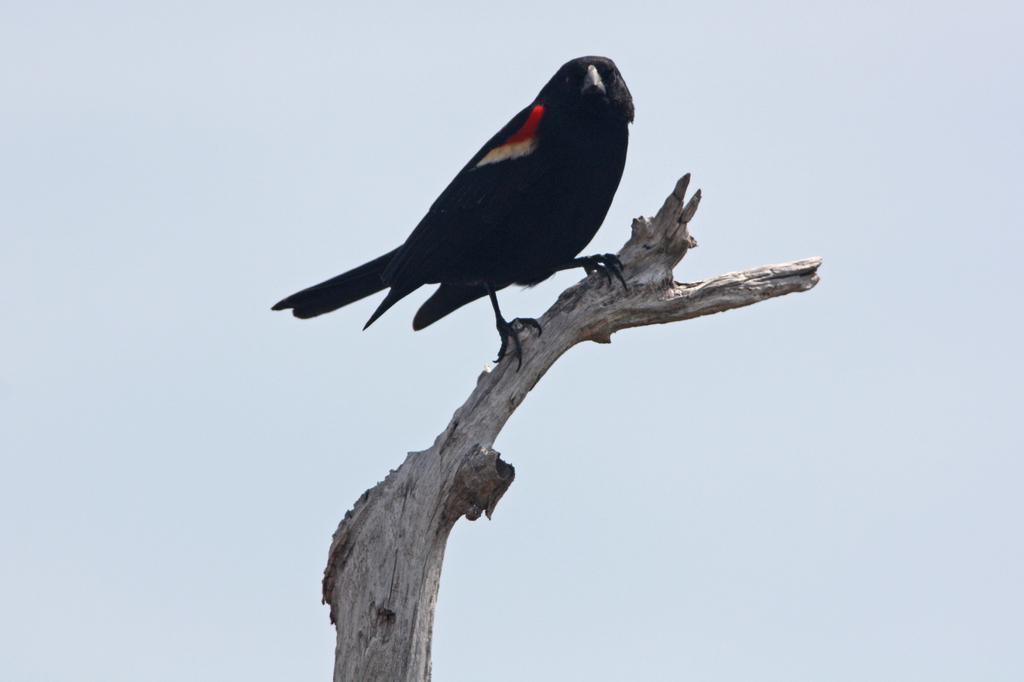Could you give a brief overview of what you see in this image? In this image, we can see a bird sitting on the stick and we can see the sky. 